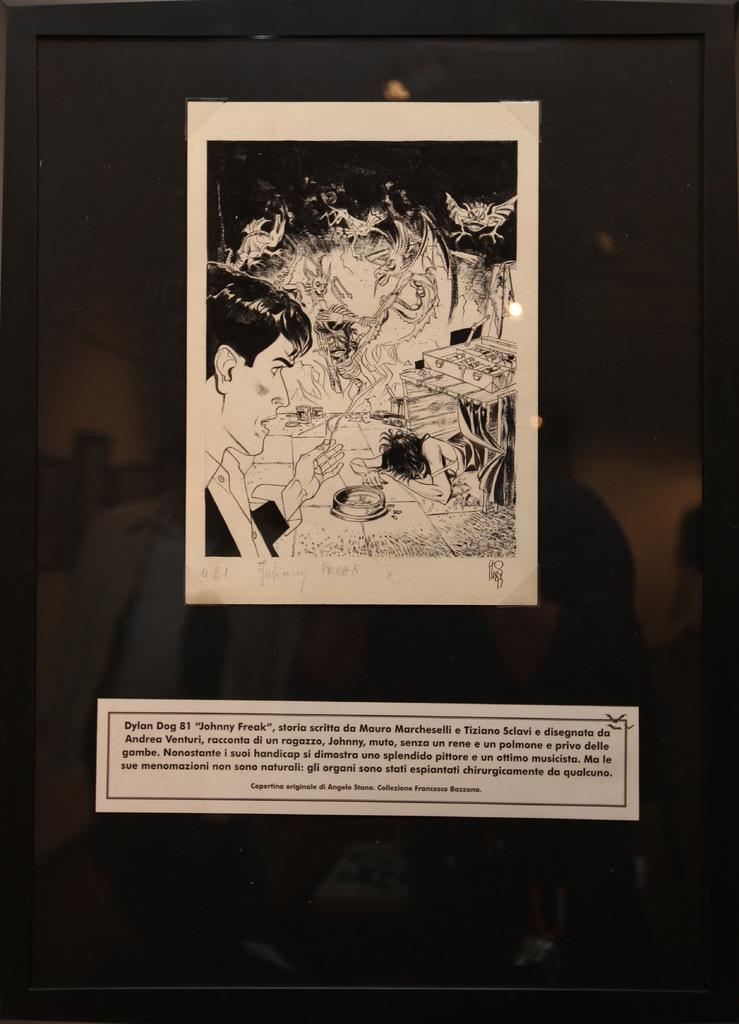<image>
Give a short and clear explanation of the subsequent image. Photo of a picture in a frame of Dylan Dog 